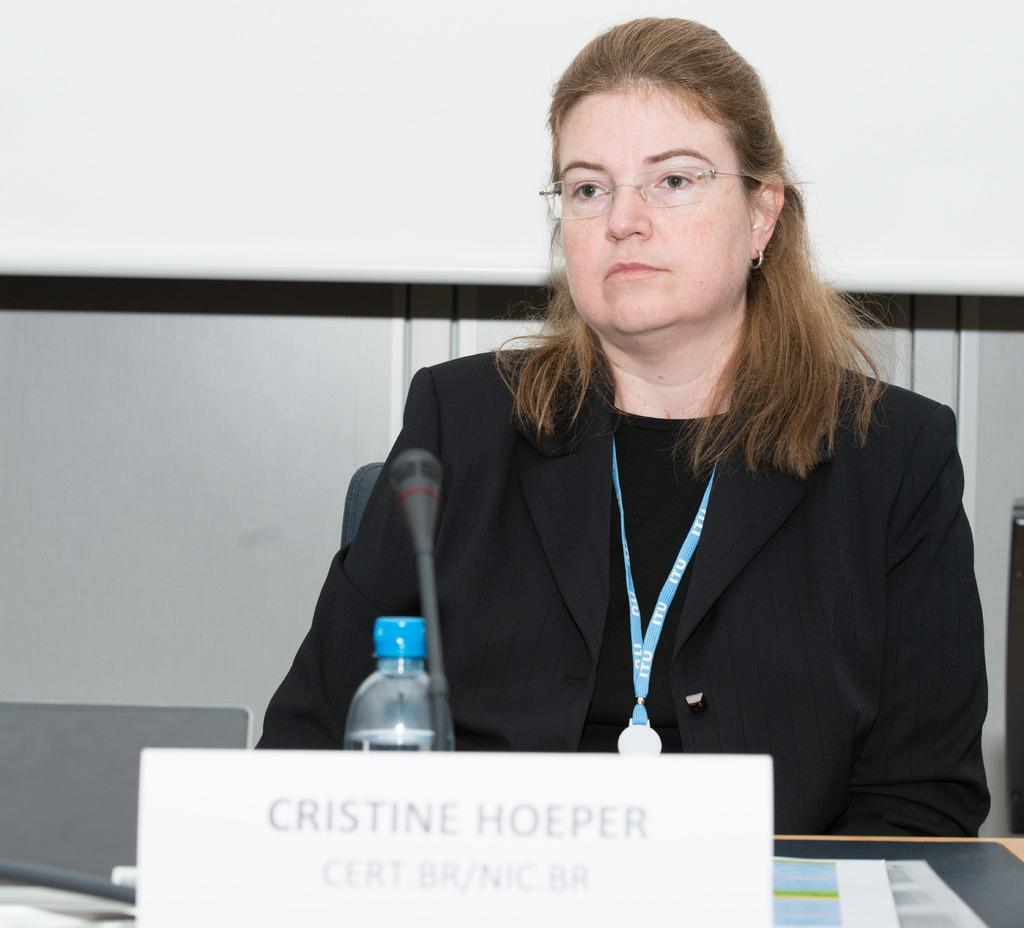What is the woman in the image doing? The woman is sitting on a chair and looking at someone. What can be seen on the table in the image? There is a wooden table in the image, and a microphone and a bottle are present on it. What might the woman be using the microphone for? The microphone suggests that the woman might be participating in a speaking event or giving a presentation. How many tomatoes are on the table in the image? There are no tomatoes present on the table in the image. Can you tell me the credit score of the woman in the image? There is no information about the woman's credit score in the image. 